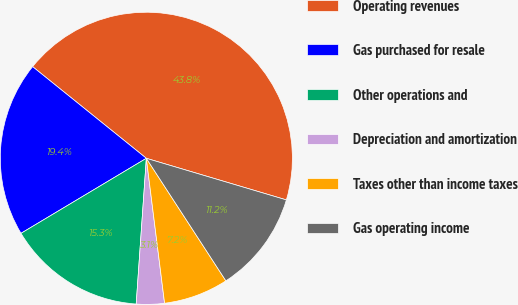Convert chart to OTSL. <chart><loc_0><loc_0><loc_500><loc_500><pie_chart><fcel>Operating revenues<fcel>Gas purchased for resale<fcel>Other operations and<fcel>Depreciation and amortization<fcel>Taxes other than income taxes<fcel>Gas operating income<nl><fcel>43.8%<fcel>19.38%<fcel>15.31%<fcel>3.1%<fcel>7.17%<fcel>11.24%<nl></chart> 